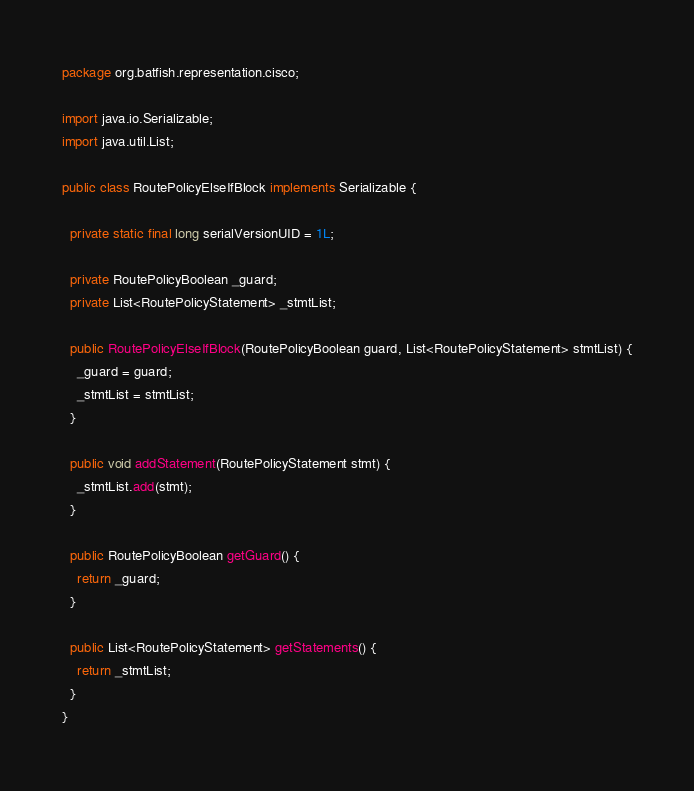<code> <loc_0><loc_0><loc_500><loc_500><_Java_>package org.batfish.representation.cisco;

import java.io.Serializable;
import java.util.List;

public class RoutePolicyElseIfBlock implements Serializable {

  private static final long serialVersionUID = 1L;

  private RoutePolicyBoolean _guard;
  private List<RoutePolicyStatement> _stmtList;

  public RoutePolicyElseIfBlock(RoutePolicyBoolean guard, List<RoutePolicyStatement> stmtList) {
    _guard = guard;
    _stmtList = stmtList;
  }

  public void addStatement(RoutePolicyStatement stmt) {
    _stmtList.add(stmt);
  }

  public RoutePolicyBoolean getGuard() {
    return _guard;
  }

  public List<RoutePolicyStatement> getStatements() {
    return _stmtList;
  }
}
</code> 